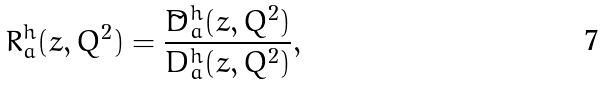<formula> <loc_0><loc_0><loc_500><loc_500>R _ { a } ^ { h } ( z , Q ^ { 2 } ) = \frac { \tilde { D } _ { a } ^ { h } ( z , Q ^ { 2 } ) } { D _ { a } ^ { h } ( z , Q ^ { 2 } ) } ,</formula> 